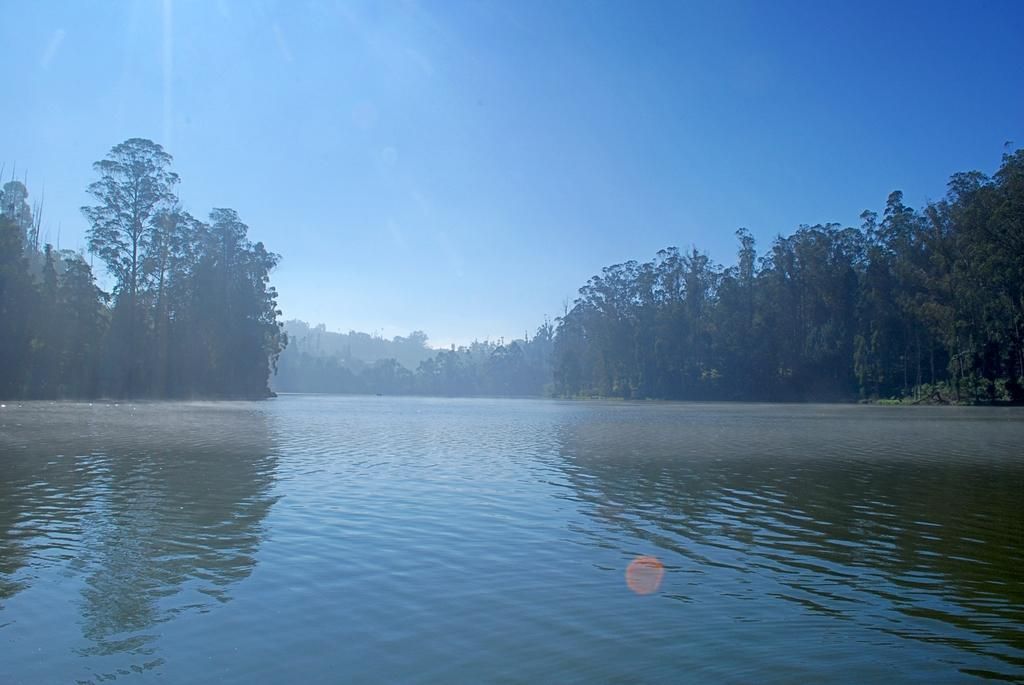What is visible in the image? There is water and trees visible in the image. Can you describe the water in the image? The water is visible, but its specific characteristics are not mentioned in the facts. What type of vegetation is present in the image? Trees are present in the image. How many dimes can be seen floating on the water in the image? There is no mention of dimes in the image, so it is not possible to answer that question. 